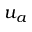<formula> <loc_0><loc_0><loc_500><loc_500>u _ { a }</formula> 